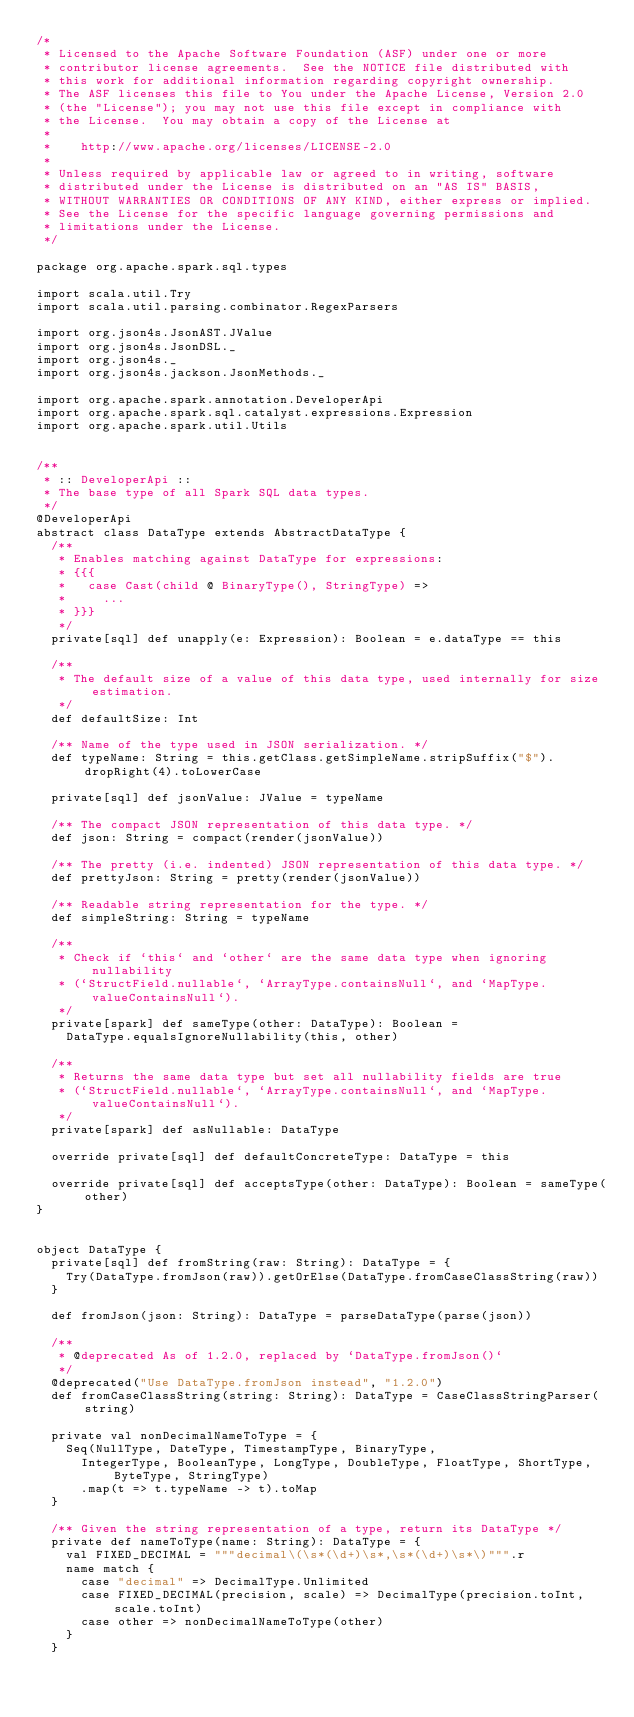Convert code to text. <code><loc_0><loc_0><loc_500><loc_500><_Scala_>/*
 * Licensed to the Apache Software Foundation (ASF) under one or more
 * contributor license agreements.  See the NOTICE file distributed with
 * this work for additional information regarding copyright ownership.
 * The ASF licenses this file to You under the Apache License, Version 2.0
 * (the "License"); you may not use this file except in compliance with
 * the License.  You may obtain a copy of the License at
 *
 *    http://www.apache.org/licenses/LICENSE-2.0
 *
 * Unless required by applicable law or agreed to in writing, software
 * distributed under the License is distributed on an "AS IS" BASIS,
 * WITHOUT WARRANTIES OR CONDITIONS OF ANY KIND, either express or implied.
 * See the License for the specific language governing permissions and
 * limitations under the License.
 */

package org.apache.spark.sql.types

import scala.util.Try
import scala.util.parsing.combinator.RegexParsers

import org.json4s.JsonAST.JValue
import org.json4s.JsonDSL._
import org.json4s._
import org.json4s.jackson.JsonMethods._

import org.apache.spark.annotation.DeveloperApi
import org.apache.spark.sql.catalyst.expressions.Expression
import org.apache.spark.util.Utils


/**
 * :: DeveloperApi ::
 * The base type of all Spark SQL data types.
 */
@DeveloperApi
abstract class DataType extends AbstractDataType {
  /**
   * Enables matching against DataType for expressions:
   * {{{
   *   case Cast(child @ BinaryType(), StringType) =>
   *     ...
   * }}}
   */
  private[sql] def unapply(e: Expression): Boolean = e.dataType == this

  /**
   * The default size of a value of this data type, used internally for size estimation.
   */
  def defaultSize: Int

  /** Name of the type used in JSON serialization. */
  def typeName: String = this.getClass.getSimpleName.stripSuffix("$").dropRight(4).toLowerCase

  private[sql] def jsonValue: JValue = typeName

  /** The compact JSON representation of this data type. */
  def json: String = compact(render(jsonValue))

  /** The pretty (i.e. indented) JSON representation of this data type. */
  def prettyJson: String = pretty(render(jsonValue))

  /** Readable string representation for the type. */
  def simpleString: String = typeName

  /**
   * Check if `this` and `other` are the same data type when ignoring nullability
   * (`StructField.nullable`, `ArrayType.containsNull`, and `MapType.valueContainsNull`).
   */
  private[spark] def sameType(other: DataType): Boolean =
    DataType.equalsIgnoreNullability(this, other)

  /**
   * Returns the same data type but set all nullability fields are true
   * (`StructField.nullable`, `ArrayType.containsNull`, and `MapType.valueContainsNull`).
   */
  private[spark] def asNullable: DataType

  override private[sql] def defaultConcreteType: DataType = this

  override private[sql] def acceptsType(other: DataType): Boolean = sameType(other)
}


object DataType {
  private[sql] def fromString(raw: String): DataType = {
    Try(DataType.fromJson(raw)).getOrElse(DataType.fromCaseClassString(raw))
  }

  def fromJson(json: String): DataType = parseDataType(parse(json))

  /**
   * @deprecated As of 1.2.0, replaced by `DataType.fromJson()`
   */
  @deprecated("Use DataType.fromJson instead", "1.2.0")
  def fromCaseClassString(string: String): DataType = CaseClassStringParser(string)

  private val nonDecimalNameToType = {
    Seq(NullType, DateType, TimestampType, BinaryType,
      IntegerType, BooleanType, LongType, DoubleType, FloatType, ShortType, ByteType, StringType)
      .map(t => t.typeName -> t).toMap
  }

  /** Given the string representation of a type, return its DataType */
  private def nameToType(name: String): DataType = {
    val FIXED_DECIMAL = """decimal\(\s*(\d+)\s*,\s*(\d+)\s*\)""".r
    name match {
      case "decimal" => DecimalType.Unlimited
      case FIXED_DECIMAL(precision, scale) => DecimalType(precision.toInt, scale.toInt)
      case other => nonDecimalNameToType(other)
    }
  }
</code> 